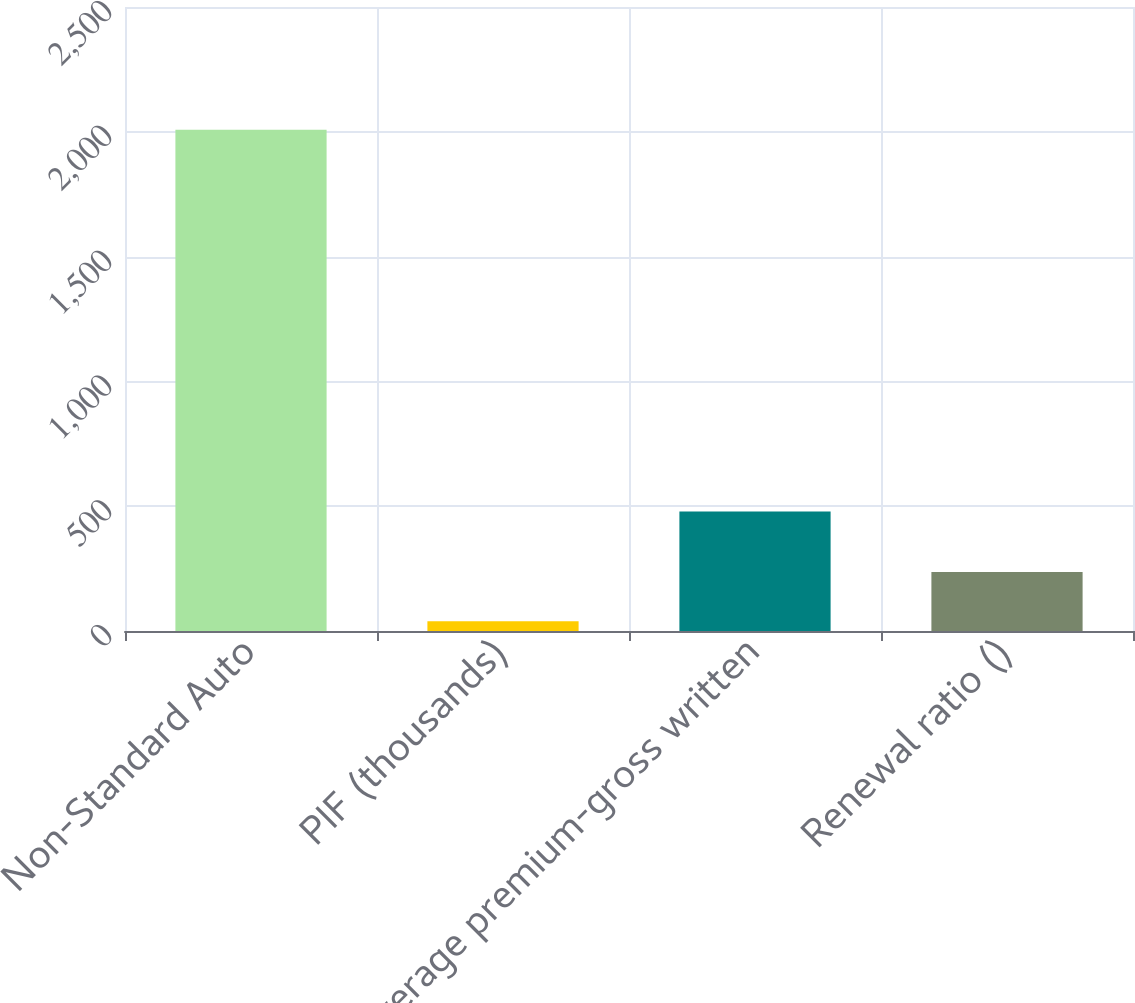<chart> <loc_0><loc_0><loc_500><loc_500><bar_chart><fcel>Non-Standard Auto<fcel>PIF (thousands)<fcel>Average premium-gross written<fcel>Renewal ratio ()<nl><fcel>2008<fcel>39<fcel>479<fcel>235.9<nl></chart> 